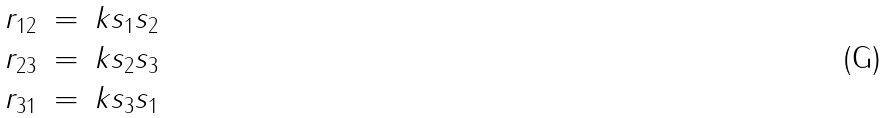Convert formula to latex. <formula><loc_0><loc_0><loc_500><loc_500>\begin{array} { r c l } r _ { 1 2 } & = & k s _ { 1 } s _ { 2 } \\ r _ { 2 3 } & = & k s _ { 2 } s _ { 3 } \\ r _ { 3 1 } & = & k s _ { 3 } s _ { 1 } \end{array}</formula> 